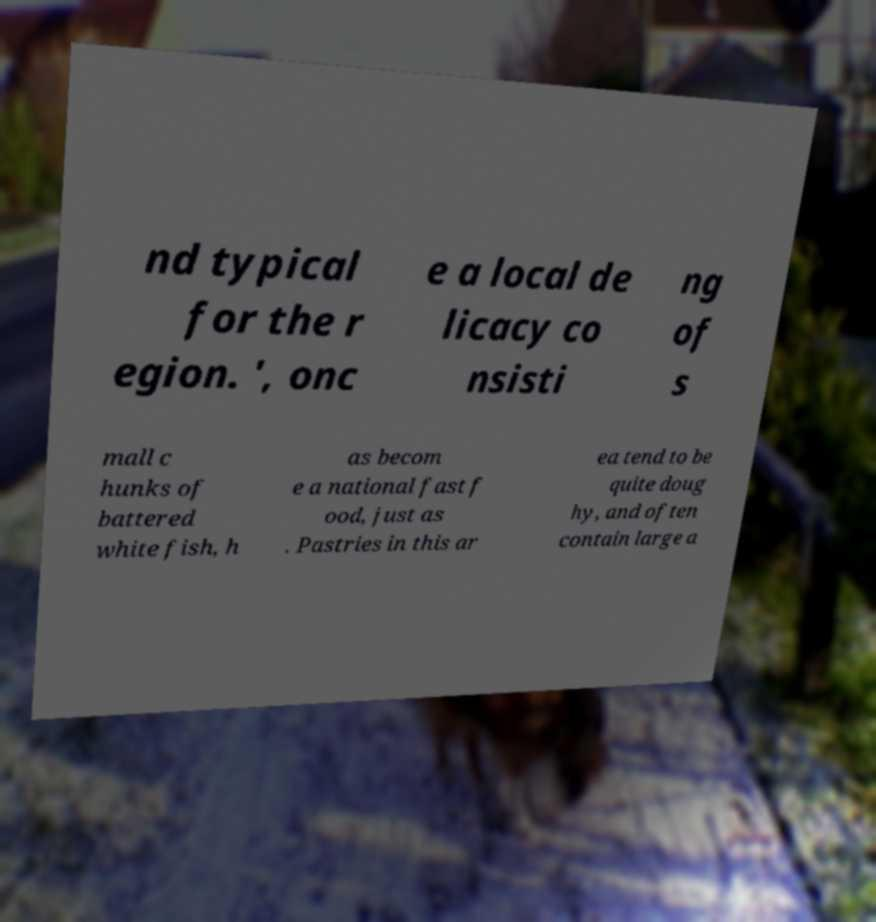I need the written content from this picture converted into text. Can you do that? nd typical for the r egion. ', onc e a local de licacy co nsisti ng of s mall c hunks of battered white fish, h as becom e a national fast f ood, just as . Pastries in this ar ea tend to be quite doug hy, and often contain large a 